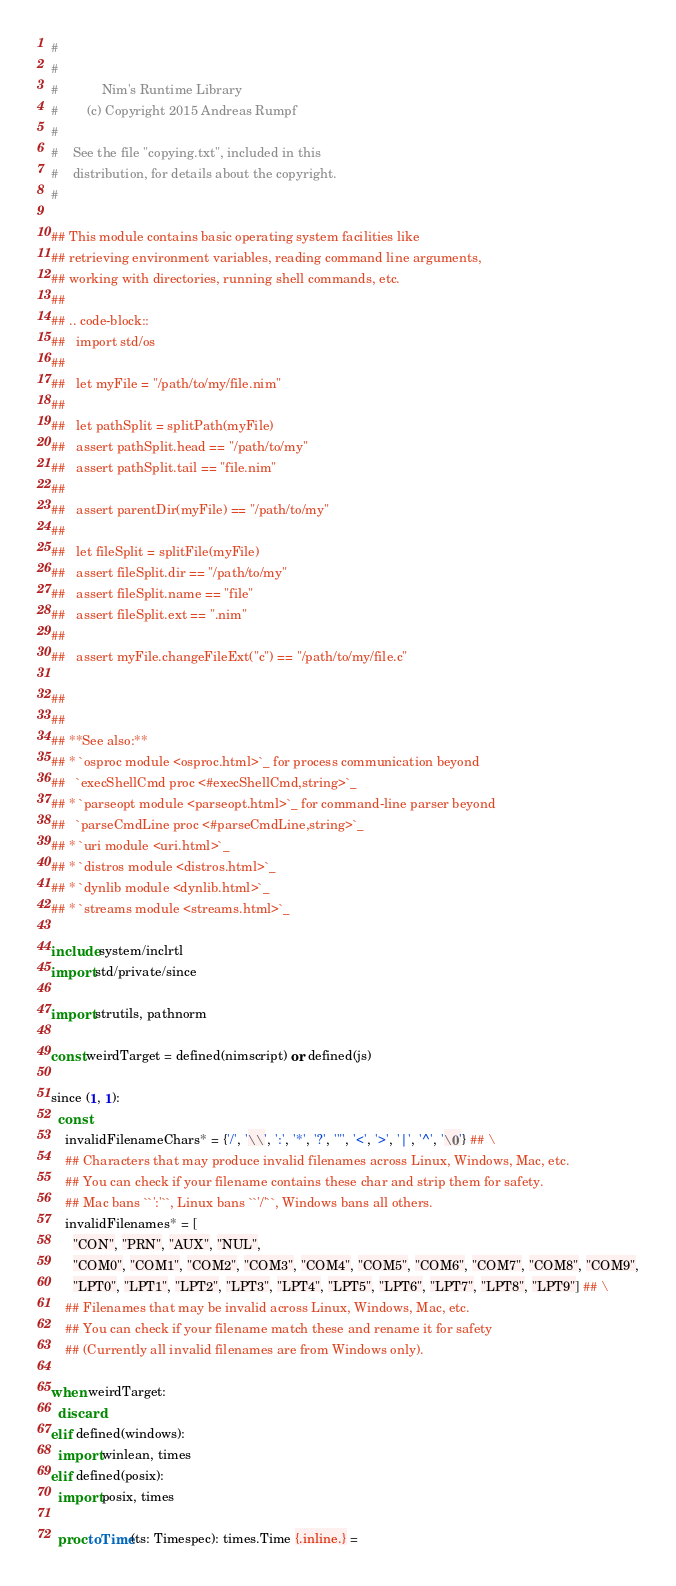<code> <loc_0><loc_0><loc_500><loc_500><_Nim_>#
#
#            Nim's Runtime Library
#        (c) Copyright 2015 Andreas Rumpf
#
#    See the file "copying.txt", included in this
#    distribution, for details about the copyright.
#

## This module contains basic operating system facilities like
## retrieving environment variables, reading command line arguments,
## working with directories, running shell commands, etc.
##
## .. code-block::
##   import std/os
##
##   let myFile = "/path/to/my/file.nim"
##
##   let pathSplit = splitPath(myFile)
##   assert pathSplit.head == "/path/to/my"
##   assert pathSplit.tail == "file.nim"
##
##   assert parentDir(myFile) == "/path/to/my"
##
##   let fileSplit = splitFile(myFile)
##   assert fileSplit.dir == "/path/to/my"
##   assert fileSplit.name == "file"
##   assert fileSplit.ext == ".nim"
##
##   assert myFile.changeFileExt("c") == "/path/to/my/file.c"

##
##
## **See also:**
## * `osproc module <osproc.html>`_ for process communication beyond
##   `execShellCmd proc <#execShellCmd,string>`_
## * `parseopt module <parseopt.html>`_ for command-line parser beyond
##   `parseCmdLine proc <#parseCmdLine,string>`_
## * `uri module <uri.html>`_
## * `distros module <distros.html>`_
## * `dynlib module <dynlib.html>`_
## * `streams module <streams.html>`_

include system/inclrtl
import std/private/since

import strutils, pathnorm

const weirdTarget = defined(nimscript) or defined(js)

since (1, 1):
  const
    invalidFilenameChars* = {'/', '\\', ':', '*', '?', '"', '<', '>', '|', '^', '\0'} ## \
    ## Characters that may produce invalid filenames across Linux, Windows, Mac, etc.
    ## You can check if your filename contains these char and strip them for safety.
    ## Mac bans ``':'``, Linux bans ``'/'``, Windows bans all others.
    invalidFilenames* = [
      "CON", "PRN", "AUX", "NUL",
      "COM0", "COM1", "COM2", "COM3", "COM4", "COM5", "COM6", "COM7", "COM8", "COM9",
      "LPT0", "LPT1", "LPT2", "LPT3", "LPT4", "LPT5", "LPT6", "LPT7", "LPT8", "LPT9"] ## \
    ## Filenames that may be invalid across Linux, Windows, Mac, etc.
    ## You can check if your filename match these and rename it for safety
    ## (Currently all invalid filenames are from Windows only).

when weirdTarget:
  discard
elif defined(windows):
  import winlean, times
elif defined(posix):
  import posix, times

  proc toTime(ts: Timespec): times.Time {.inline.} =</code> 